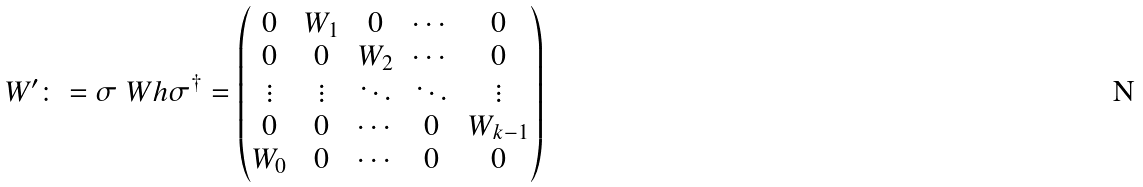<formula> <loc_0><loc_0><loc_500><loc_500>W ^ { \prime } \colon = \sigma \ W h \sigma ^ { \dagger } = \begin{pmatrix} 0 & W _ { 1 } & 0 & \cdots & 0 \\ 0 & 0 & W _ { 2 } & \cdots & 0 \\ \vdots & \vdots & \ddots & \ddots & \vdots \\ 0 & 0 & \cdots & 0 & W _ { k - 1 } \\ W _ { 0 } & 0 & \cdots & 0 & 0 \end{pmatrix}</formula> 